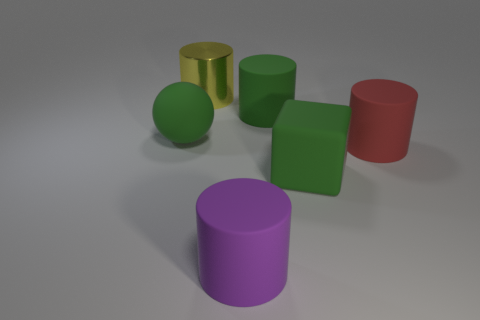There is a yellow cylinder that is the same size as the purple rubber object; what is it made of?
Provide a short and direct response. Metal. What number of other things are there of the same material as the large yellow thing
Offer a very short reply. 0. There is a rubber thing that is left of the purple cylinder; does it have the same color as the matte thing behind the ball?
Offer a terse response. Yes. There is a large green rubber thing to the right of the rubber thing behind the rubber sphere; what shape is it?
Your answer should be very brief. Cube. What number of other objects are the same color as the big rubber ball?
Give a very brief answer. 2. Is the green object that is left of the big purple cylinder made of the same material as the green thing in front of the big red rubber thing?
Ensure brevity in your answer.  Yes. What is the size of the green matte thing that is left of the purple matte cylinder?
Keep it short and to the point. Large. What is the material of the large yellow object that is the same shape as the purple matte thing?
Keep it short and to the point. Metal. What is the shape of the large green thing that is in front of the red cylinder?
Provide a succinct answer. Cube. How many big green rubber things are the same shape as the large purple thing?
Provide a succinct answer. 1. 